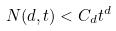Convert formula to latex. <formula><loc_0><loc_0><loc_500><loc_500>N ( d , t ) < C _ { d } t ^ { d }</formula> 